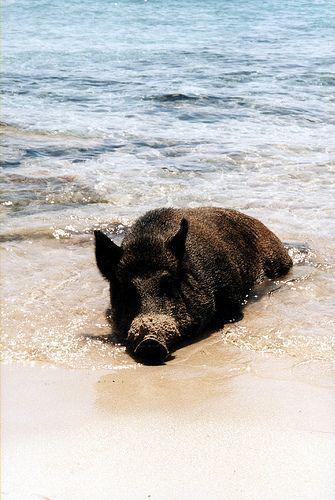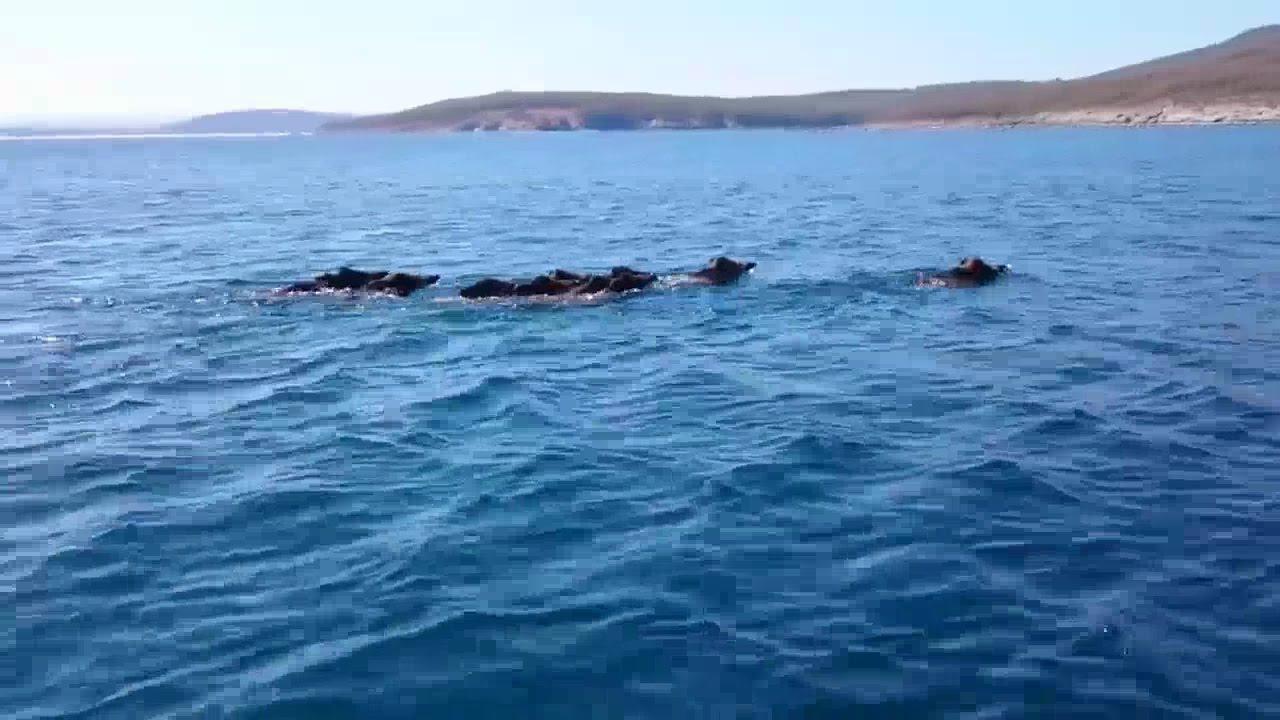The first image is the image on the left, the second image is the image on the right. Given the left and right images, does the statement "Left image shows one wild hog that is lying in shallow water at the shoreline." hold true? Answer yes or no. Yes. 